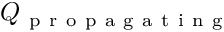<formula> <loc_0><loc_0><loc_500><loc_500>Q _ { p r o p a g a t i n g }</formula> 